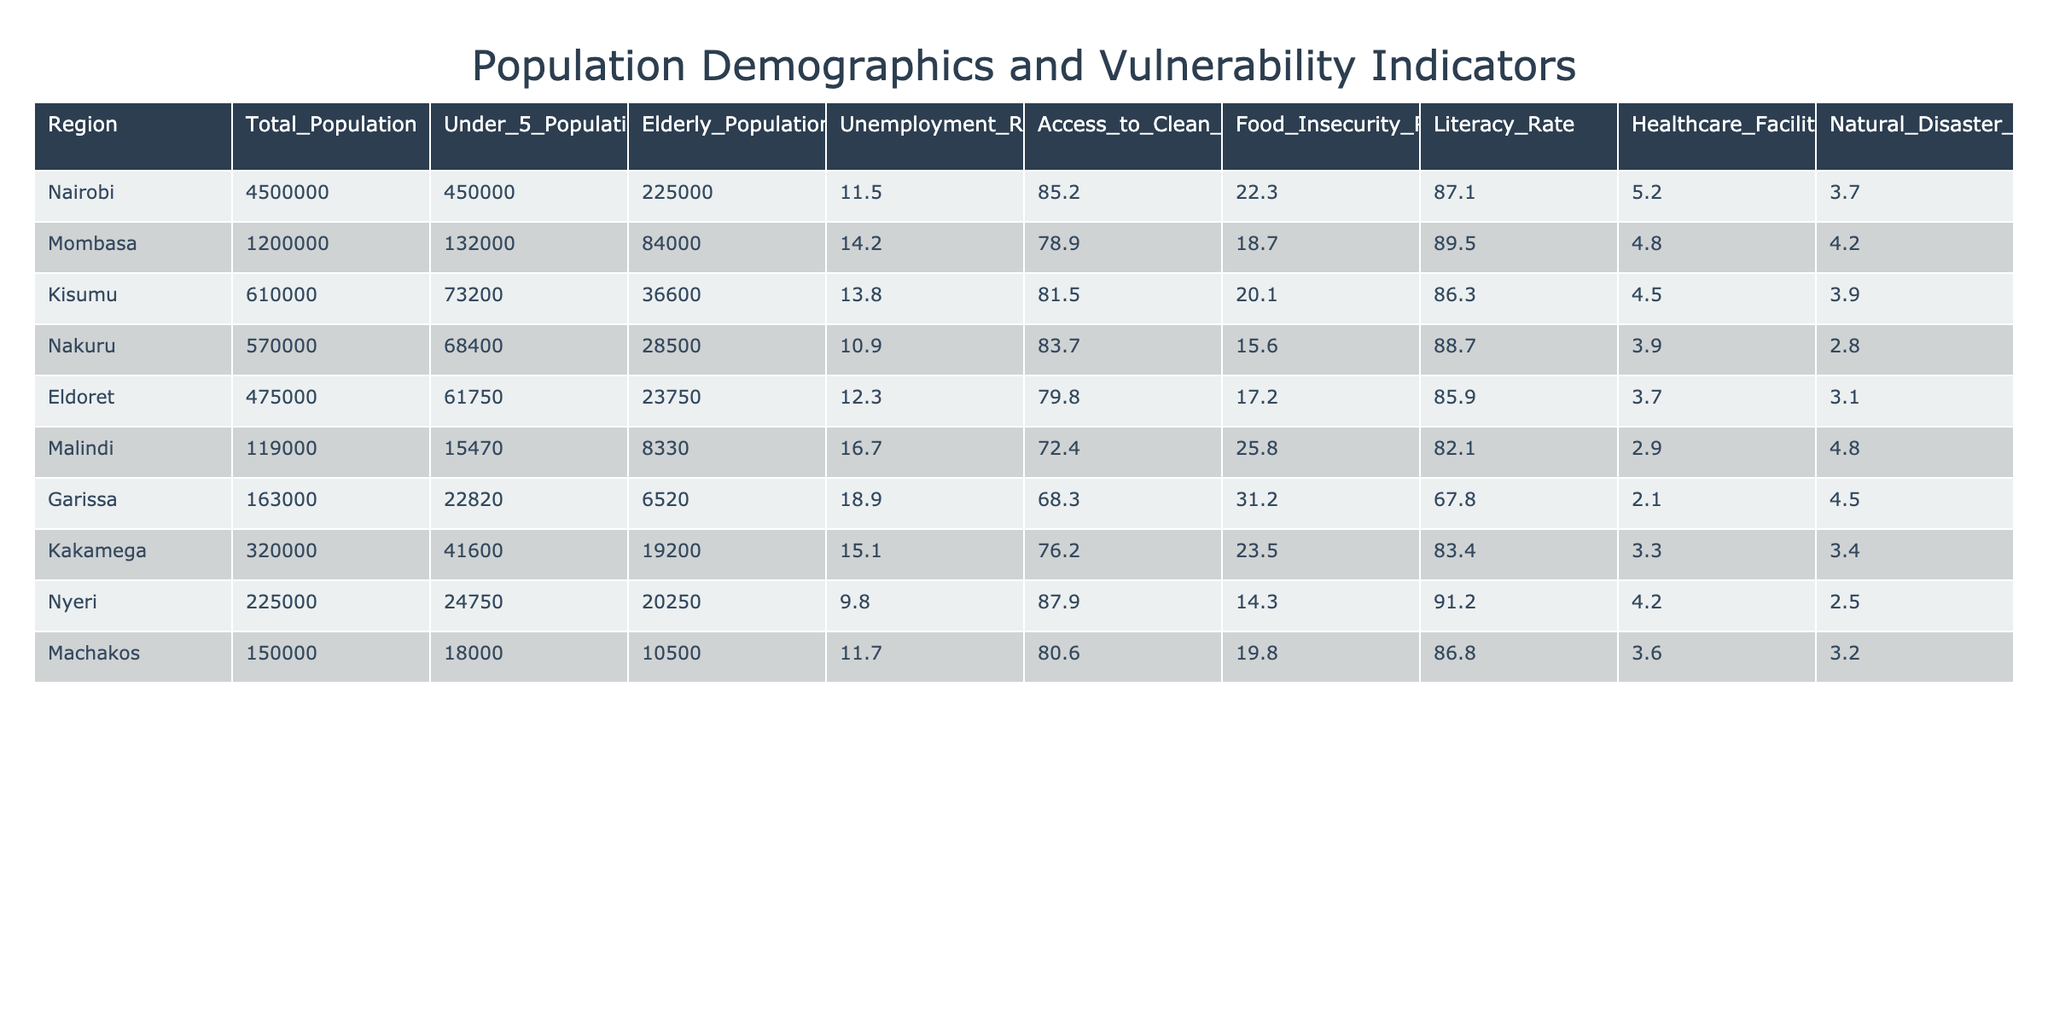What is the total population of Nairobi? The table states that the total population for Nairobi is listed under the "Total_Population" column. Looking at that entry, we can see it displays 4,500,000.
Answer: 4,500,000 Which region has the highest unemployment rate? By examining the "Unemployment_Rate" column, we compare the rates across all regions. Garissa has the highest rate at 18.9%.
Answer: Garissa What is the average food insecurity rate across all regions? To find the average, sum the food insecurity rates for all regions (22.3 + 18.7 + 20.1 + 15.6 + 17.2 + 25.8 + 31.2 + 23.5 + 14.3 + 19.8 =  213.7) and divide by the number of regions (10), which gives 213.7 / 10 = 21.37.
Answer: 21.37 Is there a region where over 30% of the population faces food insecurity? Looking closely at the "Food_Insecurity_Rate" column, Garissa has 31.2%, indicating that it exceeds the 30% threshold.
Answer: Yes What is the difference in the elderly population between Mombasa and Nakuru? First, we find the elderly populations: Mombasa has 84,000 and Nakuru has 28,500. The difference is 84,000 - 28,500 = 55,500.
Answer: 55,500 Which region has the lowest access to clean water? By analyzing the "Access_to_Clean_Water" column, we see that Malindi has the lowest percentage at 72.4%.
Answer: Malindi How many healthcare facilities per 100,000 people does Nairobi have compared to Kakamega? Nairobi has 5.2 healthcare facilities per 100,000 people, while Kakamega has 3.3. The difference is 5.2 - 3.3 = 1.9 more facilities in Nairobi.
Answer: 1.9 Which region has a literacy rate above 90% and what is it? Reviewing the "Literacy_Rate" column, Nyeri is the only region above 90%, with a literacy rate of 91.2%.
Answer: Nyeri, 91.2% What is the natural disaster risk score for the region with the highest under-5 population? The highest under-5 population is in Nairobi at 450,000, and the natural disaster risk score for Nairobi is 3.7.
Answer: 3.7 How does the total population of Eldoret compare to that of Malindi? Eldoret has a total population of 475,000 while Malindi has 119,000. The difference is 475,000 - 119,000 = 356,000 more people in Eldoret.
Answer: 356,000 